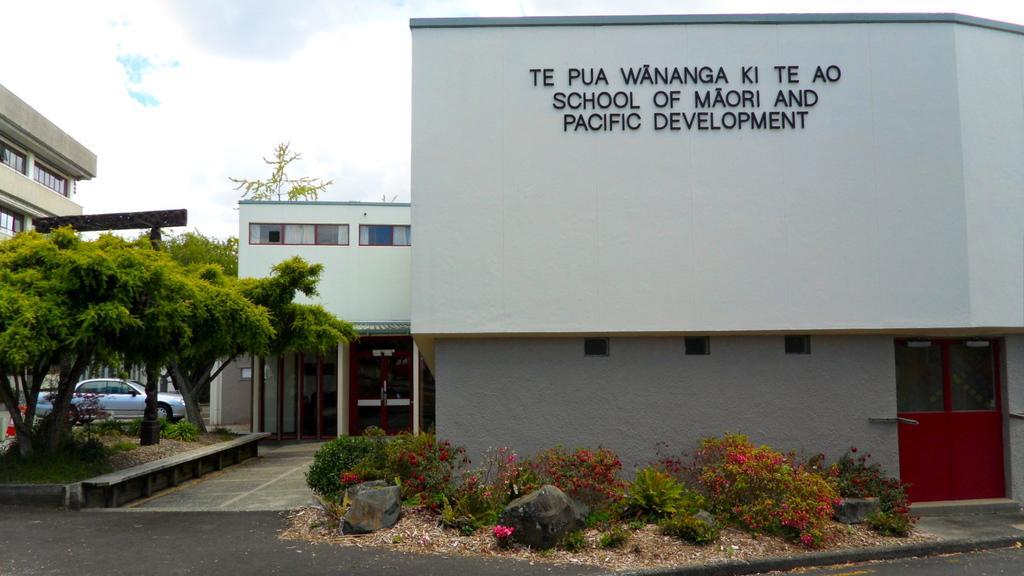Please provide a concise description of this image. In the picture we can see a house building with something written on the wall and we can see the door which is red in color and near it, we can see some plants with flowers and beside it, we can see a part of the house with glass doors and some pillars near it and beside it, we can see some trees and beside it also we can see the part of the building with glass windows and in the background we can see the sky with clouds. 